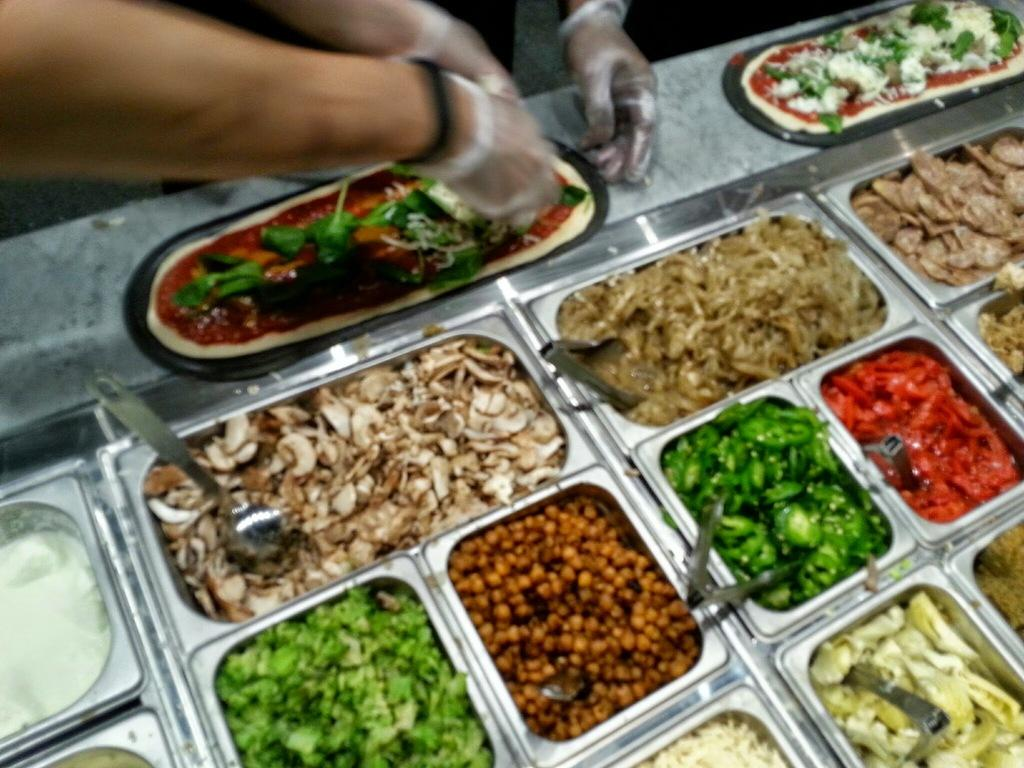What can be seen inside the food containers in the image? There are food items in food containers in the image. What can be seen on the persons' hands in the image? There are persons' hands with gloves visible in the image. What type of camera is being used to take the picture of the vase in the image? There is no camera or vase present in the image; it only shows food containers and persons' hands with gloves. 